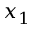Convert formula to latex. <formula><loc_0><loc_0><loc_500><loc_500>x _ { 1 }</formula> 